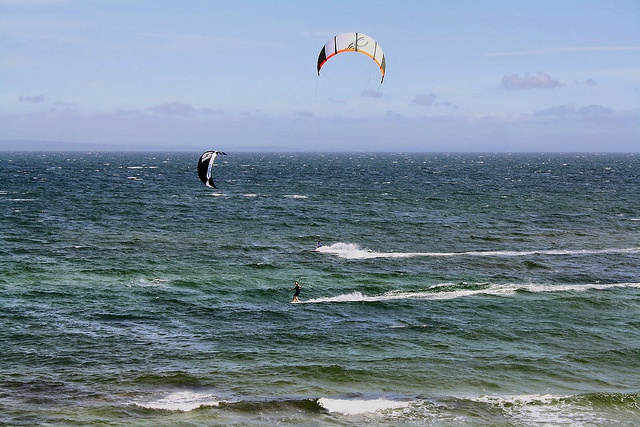Describe the objects in this image and their specific colors. I can see kite in lightblue, lightgray, black, lavender, and darkgray tones, kite in lightblue, black, lavender, gray, and darkgray tones, people in lightblue, black, gray, maroon, and teal tones, surfboard in lightblue, lightgray, black, darkgray, and gray tones, and people in lightblue, black, purple, and blue tones in this image. 